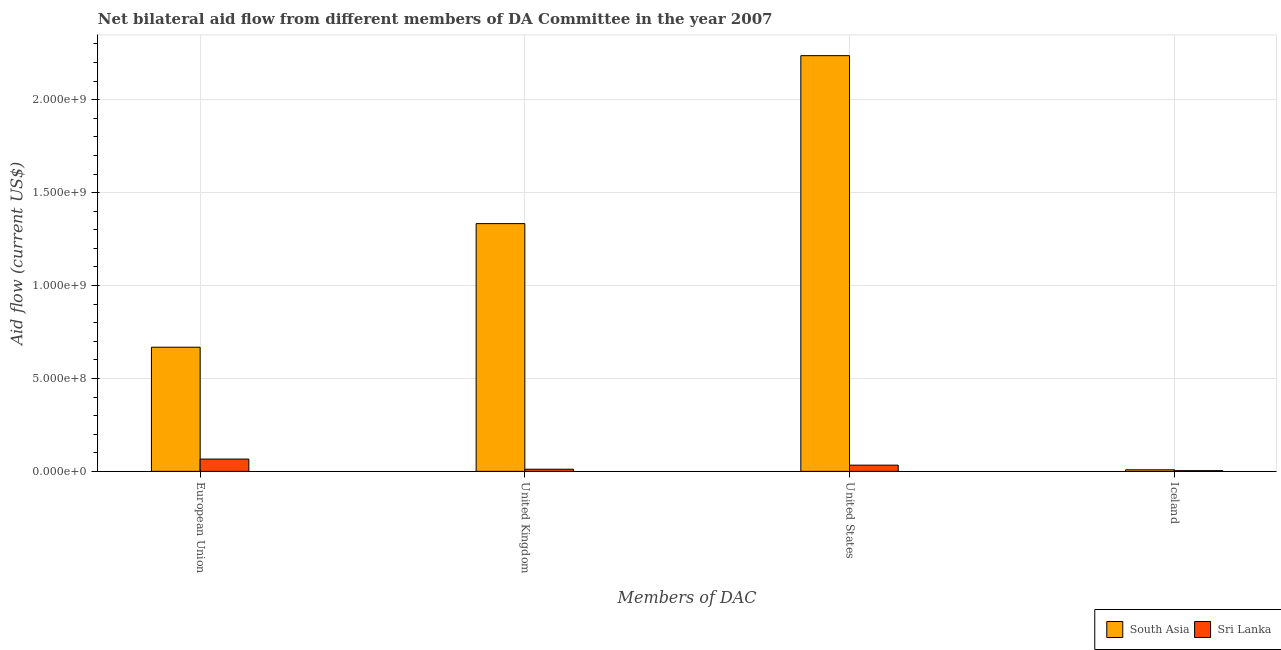How many different coloured bars are there?
Keep it short and to the point. 2. Are the number of bars on each tick of the X-axis equal?
Offer a very short reply. Yes. How many bars are there on the 1st tick from the right?
Give a very brief answer. 2. What is the label of the 4th group of bars from the left?
Your answer should be compact. Iceland. What is the amount of aid given by uk in South Asia?
Keep it short and to the point. 1.33e+09. Across all countries, what is the maximum amount of aid given by iceland?
Make the answer very short. 8.41e+06. Across all countries, what is the minimum amount of aid given by us?
Offer a very short reply. 3.35e+07. In which country was the amount of aid given by iceland maximum?
Keep it short and to the point. South Asia. In which country was the amount of aid given by uk minimum?
Your answer should be very brief. Sri Lanka. What is the total amount of aid given by uk in the graph?
Your answer should be compact. 1.34e+09. What is the difference between the amount of aid given by uk in South Asia and that in Sri Lanka?
Offer a terse response. 1.32e+09. What is the difference between the amount of aid given by uk in South Asia and the amount of aid given by us in Sri Lanka?
Ensure brevity in your answer.  1.30e+09. What is the average amount of aid given by iceland per country?
Make the answer very short. 6.12e+06. What is the difference between the amount of aid given by iceland and amount of aid given by uk in Sri Lanka?
Your answer should be compact. -7.68e+06. What is the ratio of the amount of aid given by iceland in Sri Lanka to that in South Asia?
Give a very brief answer. 0.45. Is the amount of aid given by iceland in South Asia less than that in Sri Lanka?
Offer a terse response. No. What is the difference between the highest and the second highest amount of aid given by iceland?
Your response must be concise. 4.59e+06. What is the difference between the highest and the lowest amount of aid given by eu?
Ensure brevity in your answer.  6.02e+08. In how many countries, is the amount of aid given by iceland greater than the average amount of aid given by iceland taken over all countries?
Keep it short and to the point. 1. Is the sum of the amount of aid given by us in South Asia and Sri Lanka greater than the maximum amount of aid given by eu across all countries?
Make the answer very short. Yes. What does the 2nd bar from the left in United States represents?
Make the answer very short. Sri Lanka. What does the 2nd bar from the right in European Union represents?
Give a very brief answer. South Asia. Is it the case that in every country, the sum of the amount of aid given by eu and amount of aid given by uk is greater than the amount of aid given by us?
Make the answer very short. No. How many countries are there in the graph?
Keep it short and to the point. 2. What is the difference between two consecutive major ticks on the Y-axis?
Provide a succinct answer. 5.00e+08. Are the values on the major ticks of Y-axis written in scientific E-notation?
Ensure brevity in your answer.  Yes. Does the graph contain grids?
Make the answer very short. Yes. What is the title of the graph?
Provide a succinct answer. Net bilateral aid flow from different members of DA Committee in the year 2007. Does "Papua New Guinea" appear as one of the legend labels in the graph?
Keep it short and to the point. No. What is the label or title of the X-axis?
Provide a succinct answer. Members of DAC. What is the label or title of the Y-axis?
Your answer should be very brief. Aid flow (current US$). What is the Aid flow (current US$) in South Asia in European Union?
Provide a short and direct response. 6.68e+08. What is the Aid flow (current US$) of Sri Lanka in European Union?
Provide a succinct answer. 6.61e+07. What is the Aid flow (current US$) of South Asia in United Kingdom?
Offer a very short reply. 1.33e+09. What is the Aid flow (current US$) of Sri Lanka in United Kingdom?
Offer a very short reply. 1.15e+07. What is the Aid flow (current US$) of South Asia in United States?
Keep it short and to the point. 2.24e+09. What is the Aid flow (current US$) of Sri Lanka in United States?
Keep it short and to the point. 3.35e+07. What is the Aid flow (current US$) of South Asia in Iceland?
Ensure brevity in your answer.  8.41e+06. What is the Aid flow (current US$) of Sri Lanka in Iceland?
Offer a terse response. 3.82e+06. Across all Members of DAC, what is the maximum Aid flow (current US$) in South Asia?
Ensure brevity in your answer.  2.24e+09. Across all Members of DAC, what is the maximum Aid flow (current US$) in Sri Lanka?
Make the answer very short. 6.61e+07. Across all Members of DAC, what is the minimum Aid flow (current US$) in South Asia?
Your answer should be compact. 8.41e+06. Across all Members of DAC, what is the minimum Aid flow (current US$) of Sri Lanka?
Ensure brevity in your answer.  3.82e+06. What is the total Aid flow (current US$) of South Asia in the graph?
Provide a succinct answer. 4.25e+09. What is the total Aid flow (current US$) of Sri Lanka in the graph?
Make the answer very short. 1.15e+08. What is the difference between the Aid flow (current US$) of South Asia in European Union and that in United Kingdom?
Make the answer very short. -6.65e+08. What is the difference between the Aid flow (current US$) of Sri Lanka in European Union and that in United Kingdom?
Make the answer very short. 5.46e+07. What is the difference between the Aid flow (current US$) in South Asia in European Union and that in United States?
Provide a succinct answer. -1.57e+09. What is the difference between the Aid flow (current US$) in Sri Lanka in European Union and that in United States?
Offer a terse response. 3.27e+07. What is the difference between the Aid flow (current US$) in South Asia in European Union and that in Iceland?
Make the answer very short. 6.60e+08. What is the difference between the Aid flow (current US$) of Sri Lanka in European Union and that in Iceland?
Ensure brevity in your answer.  6.23e+07. What is the difference between the Aid flow (current US$) in South Asia in United Kingdom and that in United States?
Keep it short and to the point. -9.04e+08. What is the difference between the Aid flow (current US$) in Sri Lanka in United Kingdom and that in United States?
Offer a terse response. -2.20e+07. What is the difference between the Aid flow (current US$) of South Asia in United Kingdom and that in Iceland?
Offer a very short reply. 1.32e+09. What is the difference between the Aid flow (current US$) of Sri Lanka in United Kingdom and that in Iceland?
Ensure brevity in your answer.  7.68e+06. What is the difference between the Aid flow (current US$) of South Asia in United States and that in Iceland?
Offer a very short reply. 2.23e+09. What is the difference between the Aid flow (current US$) in Sri Lanka in United States and that in Iceland?
Provide a succinct answer. 2.97e+07. What is the difference between the Aid flow (current US$) in South Asia in European Union and the Aid flow (current US$) in Sri Lanka in United Kingdom?
Offer a very short reply. 6.57e+08. What is the difference between the Aid flow (current US$) of South Asia in European Union and the Aid flow (current US$) of Sri Lanka in United States?
Provide a short and direct response. 6.35e+08. What is the difference between the Aid flow (current US$) in South Asia in European Union and the Aid flow (current US$) in Sri Lanka in Iceland?
Your response must be concise. 6.64e+08. What is the difference between the Aid flow (current US$) of South Asia in United Kingdom and the Aid flow (current US$) of Sri Lanka in United States?
Offer a very short reply. 1.30e+09. What is the difference between the Aid flow (current US$) of South Asia in United Kingdom and the Aid flow (current US$) of Sri Lanka in Iceland?
Your answer should be compact. 1.33e+09. What is the difference between the Aid flow (current US$) in South Asia in United States and the Aid flow (current US$) in Sri Lanka in Iceland?
Your answer should be compact. 2.23e+09. What is the average Aid flow (current US$) of South Asia per Members of DAC?
Offer a very short reply. 1.06e+09. What is the average Aid flow (current US$) in Sri Lanka per Members of DAC?
Make the answer very short. 2.87e+07. What is the difference between the Aid flow (current US$) of South Asia and Aid flow (current US$) of Sri Lanka in European Union?
Offer a very short reply. 6.02e+08. What is the difference between the Aid flow (current US$) in South Asia and Aid flow (current US$) in Sri Lanka in United Kingdom?
Offer a very short reply. 1.32e+09. What is the difference between the Aid flow (current US$) in South Asia and Aid flow (current US$) in Sri Lanka in United States?
Your answer should be compact. 2.20e+09. What is the difference between the Aid flow (current US$) of South Asia and Aid flow (current US$) of Sri Lanka in Iceland?
Your answer should be very brief. 4.59e+06. What is the ratio of the Aid flow (current US$) in South Asia in European Union to that in United Kingdom?
Provide a short and direct response. 0.5. What is the ratio of the Aid flow (current US$) of Sri Lanka in European Union to that in United Kingdom?
Keep it short and to the point. 5.75. What is the ratio of the Aid flow (current US$) of South Asia in European Union to that in United States?
Make the answer very short. 0.3. What is the ratio of the Aid flow (current US$) of Sri Lanka in European Union to that in United States?
Your response must be concise. 1.98. What is the ratio of the Aid flow (current US$) of South Asia in European Union to that in Iceland?
Provide a succinct answer. 79.45. What is the ratio of the Aid flow (current US$) in Sri Lanka in European Union to that in Iceland?
Your answer should be very brief. 17.31. What is the ratio of the Aid flow (current US$) of South Asia in United Kingdom to that in United States?
Make the answer very short. 0.6. What is the ratio of the Aid flow (current US$) of Sri Lanka in United Kingdom to that in United States?
Give a very brief answer. 0.34. What is the ratio of the Aid flow (current US$) of South Asia in United Kingdom to that in Iceland?
Your answer should be very brief. 158.54. What is the ratio of the Aid flow (current US$) of Sri Lanka in United Kingdom to that in Iceland?
Make the answer very short. 3.01. What is the ratio of the Aid flow (current US$) of South Asia in United States to that in Iceland?
Your answer should be very brief. 266.01. What is the ratio of the Aid flow (current US$) of Sri Lanka in United States to that in Iceland?
Make the answer very short. 8.76. What is the difference between the highest and the second highest Aid flow (current US$) in South Asia?
Your answer should be compact. 9.04e+08. What is the difference between the highest and the second highest Aid flow (current US$) in Sri Lanka?
Your answer should be compact. 3.27e+07. What is the difference between the highest and the lowest Aid flow (current US$) of South Asia?
Make the answer very short. 2.23e+09. What is the difference between the highest and the lowest Aid flow (current US$) in Sri Lanka?
Provide a succinct answer. 6.23e+07. 